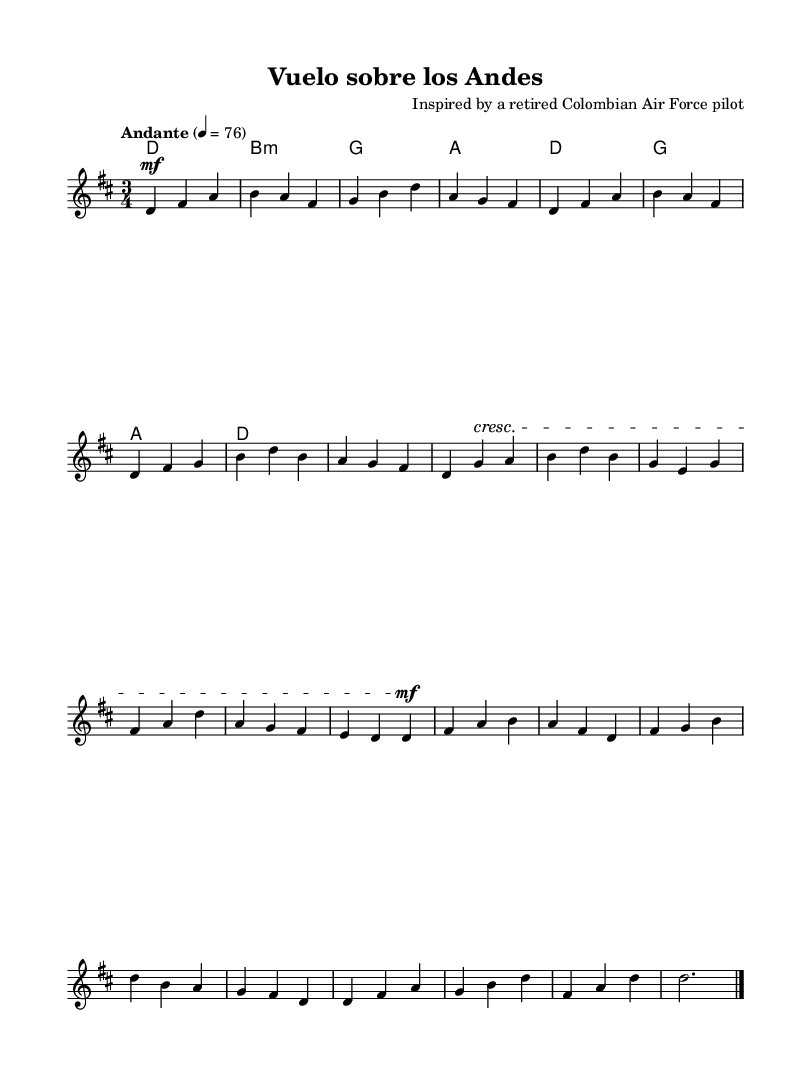What is the key signature of this music? The key signature is D major, which contains two sharps: F sharp and C sharp. This can be determined by looking for the sharp signs at the beginning of the staff.
Answer: D major What is the time signature of this piece? The time signature is 3/4, indicated at the beginning of the sheet music. This means there are three beats per measure, and each beat is a quarter note.
Answer: 3/4 What is the tempo marking for this melody? The tempo marking "Andante" indicates a moderate pace, typically around 76 beats per minute. This can be found in the tempo indication provided above the staff.
Answer: Andante How many measures are in the A section? The A section consists of 4 measures, identifiable by the distinct repetition of the melodic phrasing, which ends at a natural pause before moving to the B section.
Answer: 4 measures What is the first note of the B section? The first note of the B section is G, which is clearly marked as the first note in the measure following the A section.
Answer: G Is there a dynamic change in the B section? Yes, there is a crescendo in the B section, indicated by the symbol that shows the music gradually getting louder. This is applied to the first note of that section, highlighting its importance.
Answer: Yes What type of chords accompany the melody? The chords are primarily major and minor chords, including D, B minor, G, and A. These are shown in the chord names under the staff, representing the harmonic structure supporting the melody.
Answer: Major and minor chords 